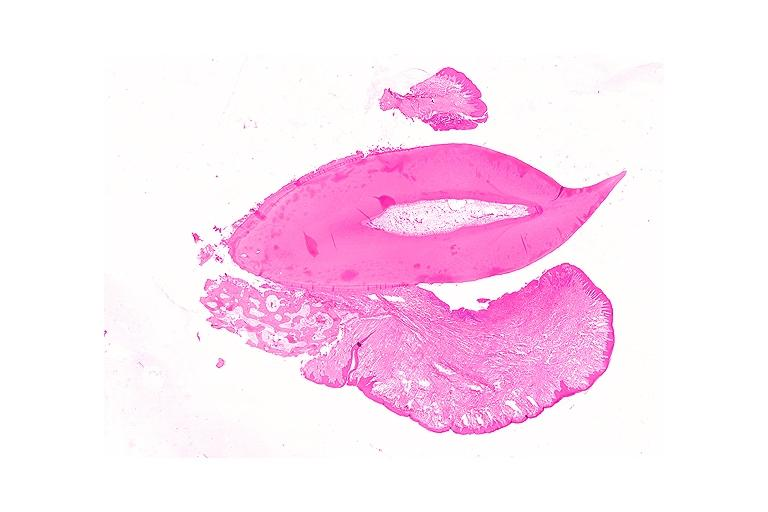where is this?
Answer the question using a single word or phrase. Oral 